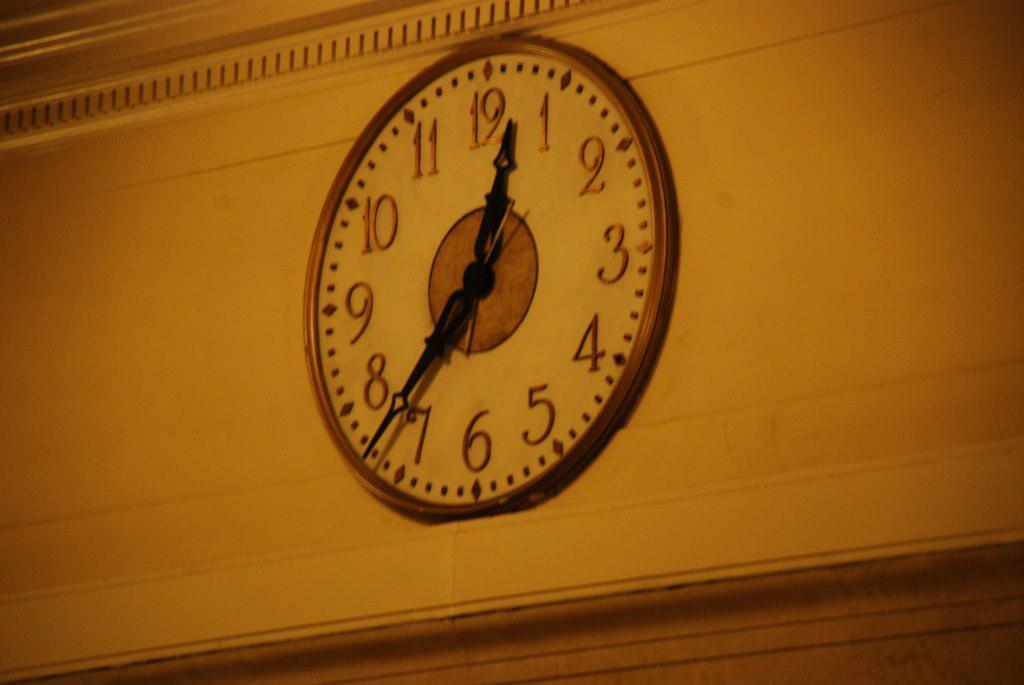<image>
Relay a brief, clear account of the picture shown. A clock on a wall says the time is currently 12:37. 